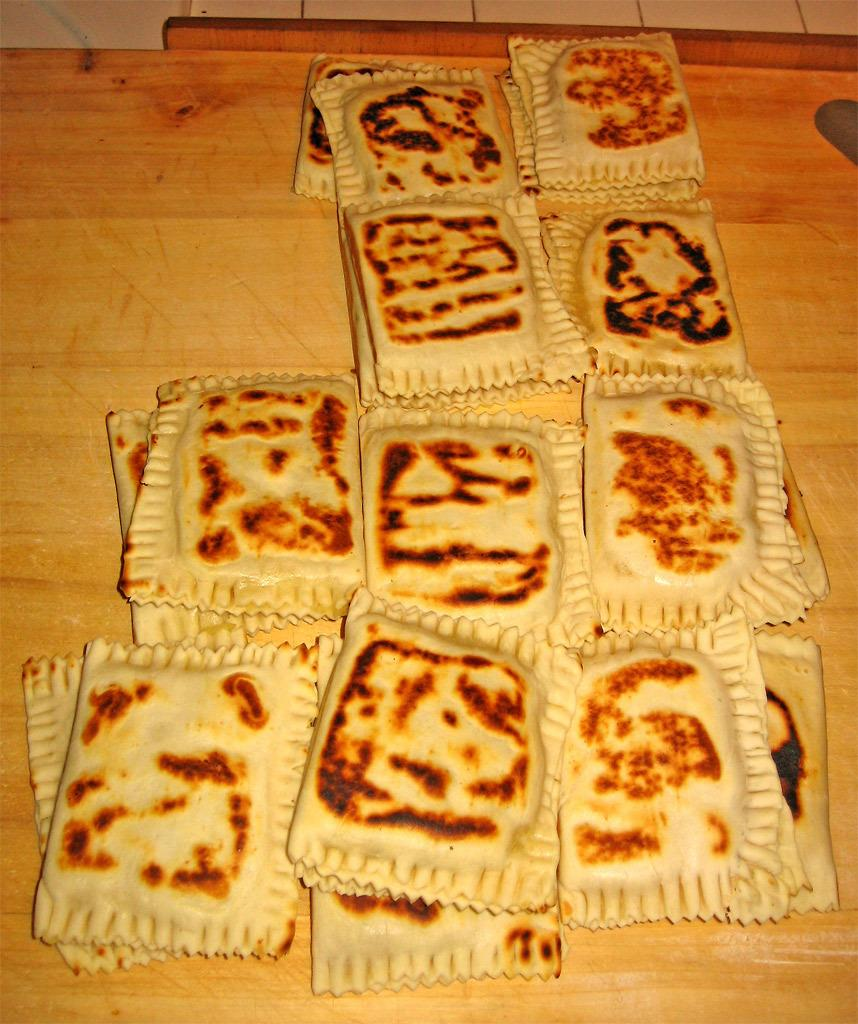What type of surface can be seen in the image? There is a wooden surface in the image. What is placed on the wooden surface? There are food items on the wooden surface in the image. What is visible at the top of the image? There is a white surface at the top of the image. What type of doctor is standing near the food items in the image? There is no doctor present in the image; it only features food items on a wooden surface and a white surface at the top. 